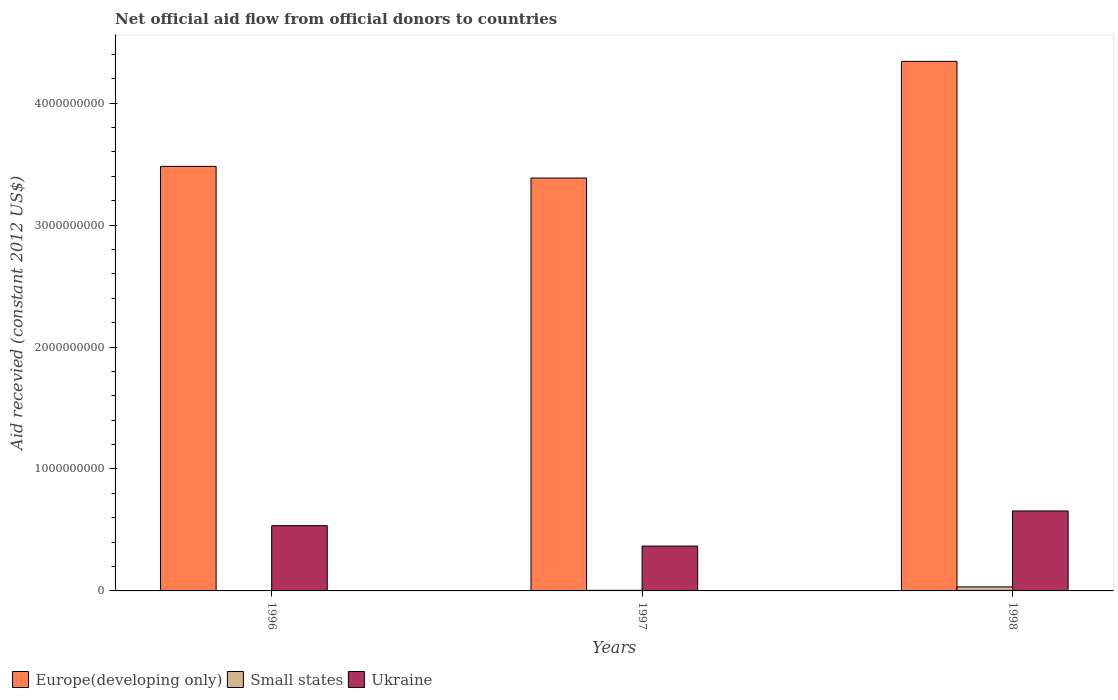Are the number of bars per tick equal to the number of legend labels?
Offer a very short reply. Yes. How many bars are there on the 3rd tick from the left?
Offer a very short reply. 3. In how many cases, is the number of bars for a given year not equal to the number of legend labels?
Your answer should be very brief. 0. What is the total aid received in Small states in 1997?
Offer a very short reply. 4.93e+06. Across all years, what is the maximum total aid received in Ukraine?
Keep it short and to the point. 6.56e+08. Across all years, what is the minimum total aid received in Small states?
Provide a succinct answer. 2.04e+06. In which year was the total aid received in Ukraine minimum?
Your answer should be very brief. 1997. What is the total total aid received in Ukraine in the graph?
Ensure brevity in your answer.  1.56e+09. What is the difference between the total aid received in Ukraine in 1997 and that in 1998?
Make the answer very short. -2.88e+08. What is the difference between the total aid received in Ukraine in 1997 and the total aid received in Europe(developing only) in 1996?
Ensure brevity in your answer.  -3.11e+09. What is the average total aid received in Ukraine per year?
Give a very brief answer. 5.20e+08. In the year 1998, what is the difference between the total aid received in Small states and total aid received in Ukraine?
Provide a succinct answer. -6.23e+08. In how many years, is the total aid received in Europe(developing only) greater than 2400000000 US$?
Offer a very short reply. 3. What is the ratio of the total aid received in Small states in 1996 to that in 1998?
Provide a short and direct response. 0.06. Is the difference between the total aid received in Small states in 1996 and 1997 greater than the difference between the total aid received in Ukraine in 1996 and 1997?
Your answer should be compact. No. What is the difference between the highest and the second highest total aid received in Ukraine?
Give a very brief answer. 1.21e+08. What is the difference between the highest and the lowest total aid received in Europe(developing only)?
Your answer should be compact. 9.57e+08. In how many years, is the total aid received in Small states greater than the average total aid received in Small states taken over all years?
Ensure brevity in your answer.  1. What does the 3rd bar from the left in 1996 represents?
Provide a short and direct response. Ukraine. What does the 3rd bar from the right in 1998 represents?
Provide a short and direct response. Europe(developing only). Is it the case that in every year, the sum of the total aid received in Europe(developing only) and total aid received in Small states is greater than the total aid received in Ukraine?
Offer a very short reply. Yes. How many bars are there?
Offer a terse response. 9. How many years are there in the graph?
Provide a succinct answer. 3. What is the difference between two consecutive major ticks on the Y-axis?
Offer a very short reply. 1.00e+09. Are the values on the major ticks of Y-axis written in scientific E-notation?
Your answer should be compact. No. Does the graph contain any zero values?
Your answer should be very brief. No. Where does the legend appear in the graph?
Make the answer very short. Bottom left. How are the legend labels stacked?
Your response must be concise. Horizontal. What is the title of the graph?
Your answer should be very brief. Net official aid flow from official donors to countries. What is the label or title of the Y-axis?
Provide a succinct answer. Aid recevied (constant 2012 US$). What is the Aid recevied (constant 2012 US$) of Europe(developing only) in 1996?
Your response must be concise. 3.48e+09. What is the Aid recevied (constant 2012 US$) in Small states in 1996?
Make the answer very short. 2.04e+06. What is the Aid recevied (constant 2012 US$) in Ukraine in 1996?
Keep it short and to the point. 5.35e+08. What is the Aid recevied (constant 2012 US$) of Europe(developing only) in 1997?
Ensure brevity in your answer.  3.39e+09. What is the Aid recevied (constant 2012 US$) in Small states in 1997?
Keep it short and to the point. 4.93e+06. What is the Aid recevied (constant 2012 US$) of Ukraine in 1997?
Provide a succinct answer. 3.68e+08. What is the Aid recevied (constant 2012 US$) of Europe(developing only) in 1998?
Ensure brevity in your answer.  4.34e+09. What is the Aid recevied (constant 2012 US$) in Small states in 1998?
Offer a very short reply. 3.29e+07. What is the Aid recevied (constant 2012 US$) in Ukraine in 1998?
Provide a short and direct response. 6.56e+08. Across all years, what is the maximum Aid recevied (constant 2012 US$) of Europe(developing only)?
Your response must be concise. 4.34e+09. Across all years, what is the maximum Aid recevied (constant 2012 US$) in Small states?
Ensure brevity in your answer.  3.29e+07. Across all years, what is the maximum Aid recevied (constant 2012 US$) in Ukraine?
Offer a very short reply. 6.56e+08. Across all years, what is the minimum Aid recevied (constant 2012 US$) of Europe(developing only)?
Your response must be concise. 3.39e+09. Across all years, what is the minimum Aid recevied (constant 2012 US$) of Small states?
Keep it short and to the point. 2.04e+06. Across all years, what is the minimum Aid recevied (constant 2012 US$) in Ukraine?
Provide a short and direct response. 3.68e+08. What is the total Aid recevied (constant 2012 US$) of Europe(developing only) in the graph?
Ensure brevity in your answer.  1.12e+1. What is the total Aid recevied (constant 2012 US$) of Small states in the graph?
Make the answer very short. 3.99e+07. What is the total Aid recevied (constant 2012 US$) of Ukraine in the graph?
Make the answer very short. 1.56e+09. What is the difference between the Aid recevied (constant 2012 US$) in Europe(developing only) in 1996 and that in 1997?
Make the answer very short. 9.58e+07. What is the difference between the Aid recevied (constant 2012 US$) in Small states in 1996 and that in 1997?
Offer a terse response. -2.89e+06. What is the difference between the Aid recevied (constant 2012 US$) in Ukraine in 1996 and that in 1997?
Ensure brevity in your answer.  1.67e+08. What is the difference between the Aid recevied (constant 2012 US$) of Europe(developing only) in 1996 and that in 1998?
Your answer should be compact. -8.61e+08. What is the difference between the Aid recevied (constant 2012 US$) in Small states in 1996 and that in 1998?
Give a very brief answer. -3.09e+07. What is the difference between the Aid recevied (constant 2012 US$) in Ukraine in 1996 and that in 1998?
Provide a short and direct response. -1.21e+08. What is the difference between the Aid recevied (constant 2012 US$) of Europe(developing only) in 1997 and that in 1998?
Offer a terse response. -9.57e+08. What is the difference between the Aid recevied (constant 2012 US$) in Small states in 1997 and that in 1998?
Give a very brief answer. -2.80e+07. What is the difference between the Aid recevied (constant 2012 US$) of Ukraine in 1997 and that in 1998?
Give a very brief answer. -2.88e+08. What is the difference between the Aid recevied (constant 2012 US$) in Europe(developing only) in 1996 and the Aid recevied (constant 2012 US$) in Small states in 1997?
Offer a very short reply. 3.48e+09. What is the difference between the Aid recevied (constant 2012 US$) of Europe(developing only) in 1996 and the Aid recevied (constant 2012 US$) of Ukraine in 1997?
Offer a very short reply. 3.11e+09. What is the difference between the Aid recevied (constant 2012 US$) of Small states in 1996 and the Aid recevied (constant 2012 US$) of Ukraine in 1997?
Your response must be concise. -3.66e+08. What is the difference between the Aid recevied (constant 2012 US$) in Europe(developing only) in 1996 and the Aid recevied (constant 2012 US$) in Small states in 1998?
Your answer should be very brief. 3.45e+09. What is the difference between the Aid recevied (constant 2012 US$) in Europe(developing only) in 1996 and the Aid recevied (constant 2012 US$) in Ukraine in 1998?
Give a very brief answer. 2.83e+09. What is the difference between the Aid recevied (constant 2012 US$) in Small states in 1996 and the Aid recevied (constant 2012 US$) in Ukraine in 1998?
Provide a short and direct response. -6.54e+08. What is the difference between the Aid recevied (constant 2012 US$) in Europe(developing only) in 1997 and the Aid recevied (constant 2012 US$) in Small states in 1998?
Your answer should be very brief. 3.35e+09. What is the difference between the Aid recevied (constant 2012 US$) of Europe(developing only) in 1997 and the Aid recevied (constant 2012 US$) of Ukraine in 1998?
Provide a succinct answer. 2.73e+09. What is the difference between the Aid recevied (constant 2012 US$) of Small states in 1997 and the Aid recevied (constant 2012 US$) of Ukraine in 1998?
Your answer should be compact. -6.51e+08. What is the average Aid recevied (constant 2012 US$) of Europe(developing only) per year?
Offer a very short reply. 3.74e+09. What is the average Aid recevied (constant 2012 US$) in Small states per year?
Make the answer very short. 1.33e+07. What is the average Aid recevied (constant 2012 US$) in Ukraine per year?
Your answer should be very brief. 5.20e+08. In the year 1996, what is the difference between the Aid recevied (constant 2012 US$) of Europe(developing only) and Aid recevied (constant 2012 US$) of Small states?
Offer a very short reply. 3.48e+09. In the year 1996, what is the difference between the Aid recevied (constant 2012 US$) of Europe(developing only) and Aid recevied (constant 2012 US$) of Ukraine?
Provide a short and direct response. 2.95e+09. In the year 1996, what is the difference between the Aid recevied (constant 2012 US$) of Small states and Aid recevied (constant 2012 US$) of Ukraine?
Offer a very short reply. -5.33e+08. In the year 1997, what is the difference between the Aid recevied (constant 2012 US$) in Europe(developing only) and Aid recevied (constant 2012 US$) in Small states?
Offer a terse response. 3.38e+09. In the year 1997, what is the difference between the Aid recevied (constant 2012 US$) of Europe(developing only) and Aid recevied (constant 2012 US$) of Ukraine?
Offer a very short reply. 3.02e+09. In the year 1997, what is the difference between the Aid recevied (constant 2012 US$) in Small states and Aid recevied (constant 2012 US$) in Ukraine?
Provide a short and direct response. -3.63e+08. In the year 1998, what is the difference between the Aid recevied (constant 2012 US$) in Europe(developing only) and Aid recevied (constant 2012 US$) in Small states?
Keep it short and to the point. 4.31e+09. In the year 1998, what is the difference between the Aid recevied (constant 2012 US$) in Europe(developing only) and Aid recevied (constant 2012 US$) in Ukraine?
Offer a terse response. 3.69e+09. In the year 1998, what is the difference between the Aid recevied (constant 2012 US$) in Small states and Aid recevied (constant 2012 US$) in Ukraine?
Your answer should be compact. -6.23e+08. What is the ratio of the Aid recevied (constant 2012 US$) of Europe(developing only) in 1996 to that in 1997?
Offer a terse response. 1.03. What is the ratio of the Aid recevied (constant 2012 US$) in Small states in 1996 to that in 1997?
Your answer should be compact. 0.41. What is the ratio of the Aid recevied (constant 2012 US$) in Ukraine in 1996 to that in 1997?
Your response must be concise. 1.45. What is the ratio of the Aid recevied (constant 2012 US$) of Europe(developing only) in 1996 to that in 1998?
Provide a short and direct response. 0.8. What is the ratio of the Aid recevied (constant 2012 US$) of Small states in 1996 to that in 1998?
Make the answer very short. 0.06. What is the ratio of the Aid recevied (constant 2012 US$) in Ukraine in 1996 to that in 1998?
Provide a succinct answer. 0.82. What is the ratio of the Aid recevied (constant 2012 US$) in Europe(developing only) in 1997 to that in 1998?
Your answer should be very brief. 0.78. What is the ratio of the Aid recevied (constant 2012 US$) in Small states in 1997 to that in 1998?
Offer a very short reply. 0.15. What is the ratio of the Aid recevied (constant 2012 US$) of Ukraine in 1997 to that in 1998?
Offer a very short reply. 0.56. What is the difference between the highest and the second highest Aid recevied (constant 2012 US$) of Europe(developing only)?
Offer a terse response. 8.61e+08. What is the difference between the highest and the second highest Aid recevied (constant 2012 US$) in Small states?
Your answer should be compact. 2.80e+07. What is the difference between the highest and the second highest Aid recevied (constant 2012 US$) in Ukraine?
Provide a succinct answer. 1.21e+08. What is the difference between the highest and the lowest Aid recevied (constant 2012 US$) in Europe(developing only)?
Provide a succinct answer. 9.57e+08. What is the difference between the highest and the lowest Aid recevied (constant 2012 US$) in Small states?
Your response must be concise. 3.09e+07. What is the difference between the highest and the lowest Aid recevied (constant 2012 US$) in Ukraine?
Offer a very short reply. 2.88e+08. 